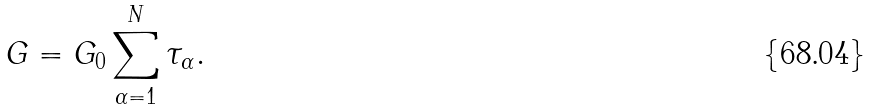<formula> <loc_0><loc_0><loc_500><loc_500>G = G _ { 0 } \sum _ { \alpha = 1 } ^ { N } \tau _ { \alpha } .</formula> 